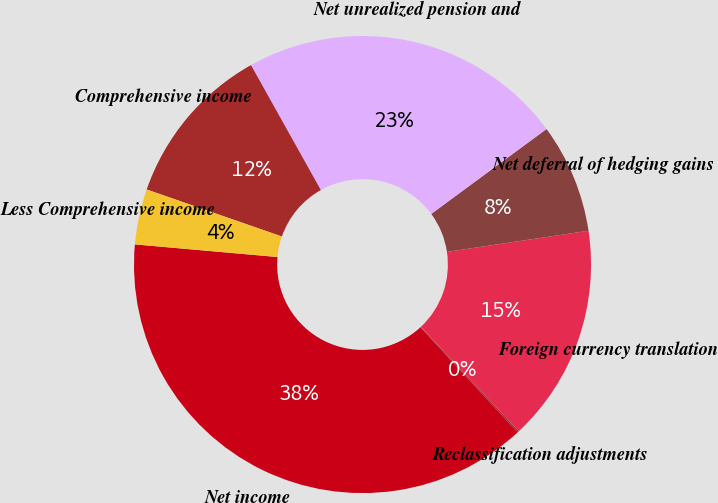<chart> <loc_0><loc_0><loc_500><loc_500><pie_chart><fcel>Net income<fcel>Reclassification adjustments<fcel>Foreign currency translation<fcel>Net deferral of hedging gains<fcel>Net unrealized pension and<fcel>Comprehensive income<fcel>Less Comprehensive income<nl><fcel>38.28%<fcel>0.11%<fcel>15.38%<fcel>7.74%<fcel>23.01%<fcel>11.56%<fcel>3.92%<nl></chart> 